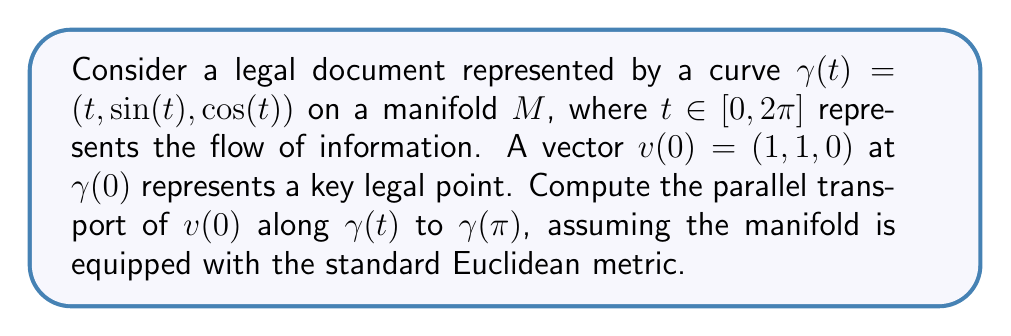Teach me how to tackle this problem. To solve this problem, we'll follow these steps:

1) First, we need to find the tangent vector to the curve $\gamma(t)$:
   $$\gamma'(t) = (1, \cos(t), -\sin(t))$$

2) The parallel transport equation in Euclidean space is:
   $$\frac{dv}{dt} + \langle v, \frac{d\gamma}{dt} \rangle \frac{d\gamma}{dt} = 0$$

3) Let $v(t) = (x(t), y(t), z(t))$ be the parallel transported vector. Substituting into the equation:
   $$\left(\frac{dx}{dt}, \frac{dy}{dt}, \frac{dz}{dt}\right) + (x + y\cos(t) - z\sin(t))(1, \cos(t), -\sin(t)) = (0, 0, 0)$$

4) This gives us a system of differential equations:
   $$\frac{dx}{dt} + x + y\cos(t) - z\sin(t) = 0$$
   $$\frac{dy}{dt} + (x + y\cos(t) - z\sin(t))\cos(t) = 0$$
   $$\frac{dz}{dt} - (x + y\cos(t) - z\sin(t))\sin(t) = 0$$

5) Given the initial condition $v(0) = (1, 1, 0)$, we can solve this system numerically or observe that the solution preserves the magnitude and angle with $\gamma'(t)$. Therefore:
   $$v(t) = (\cos(t), \cos(t), -\sin(t))$$

6) At $t = \pi$, we have:
   $$v(\pi) = (-1, -1, 0)$$

This result shows that the key legal point, represented by the vector, has been "flipped" in the first two components as it progressed through half of the document's flow.
Answer: $v(\pi) = (-1, -1, 0)$ 